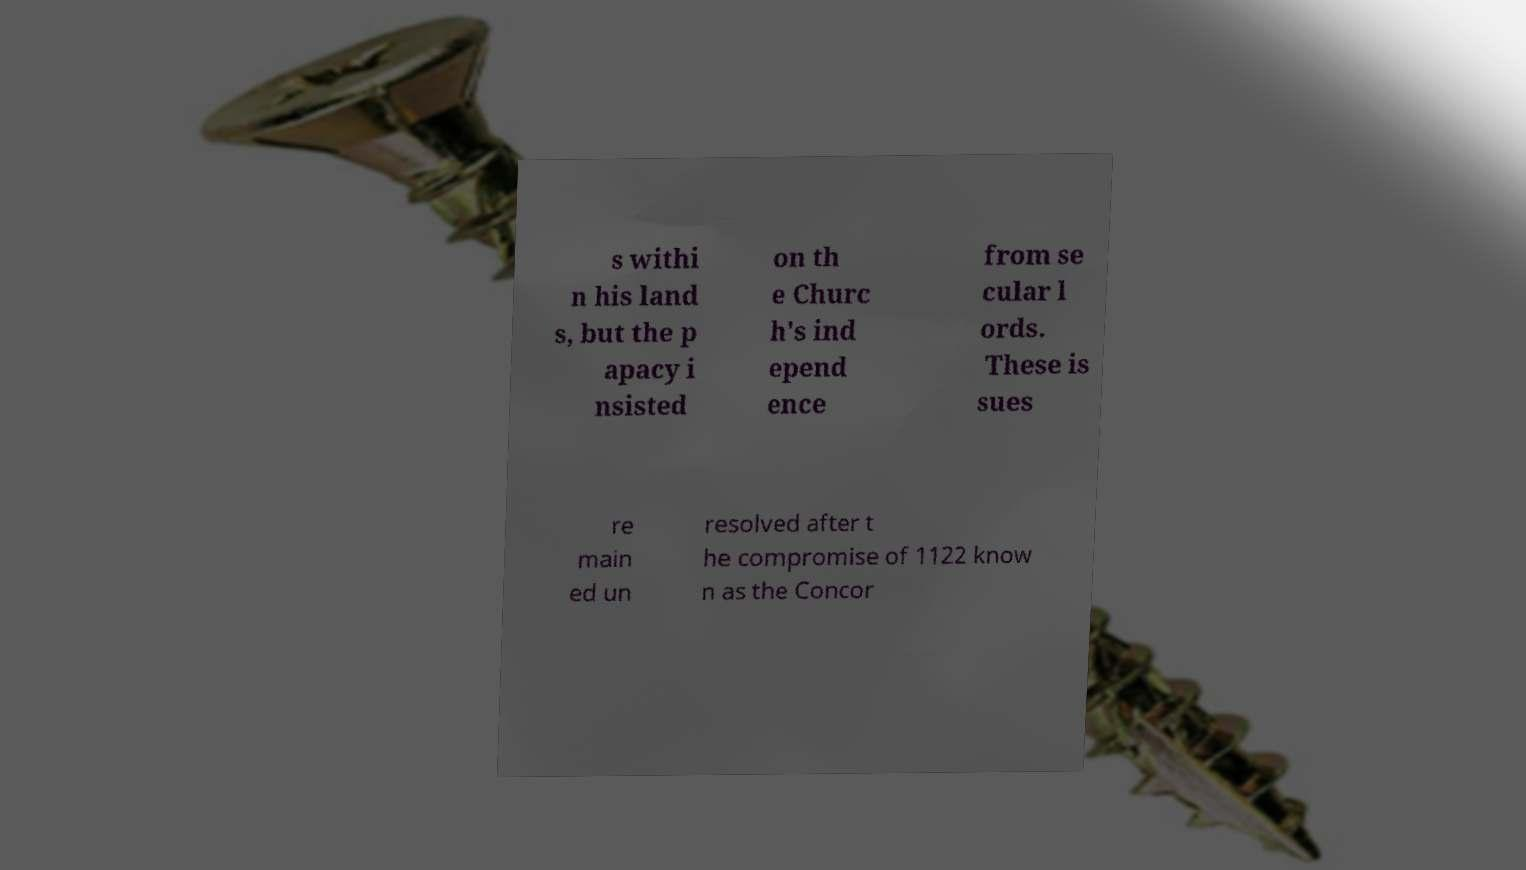I need the written content from this picture converted into text. Can you do that? s withi n his land s, but the p apacy i nsisted on th e Churc h's ind epend ence from se cular l ords. These is sues re main ed un resolved after t he compromise of 1122 know n as the Concor 